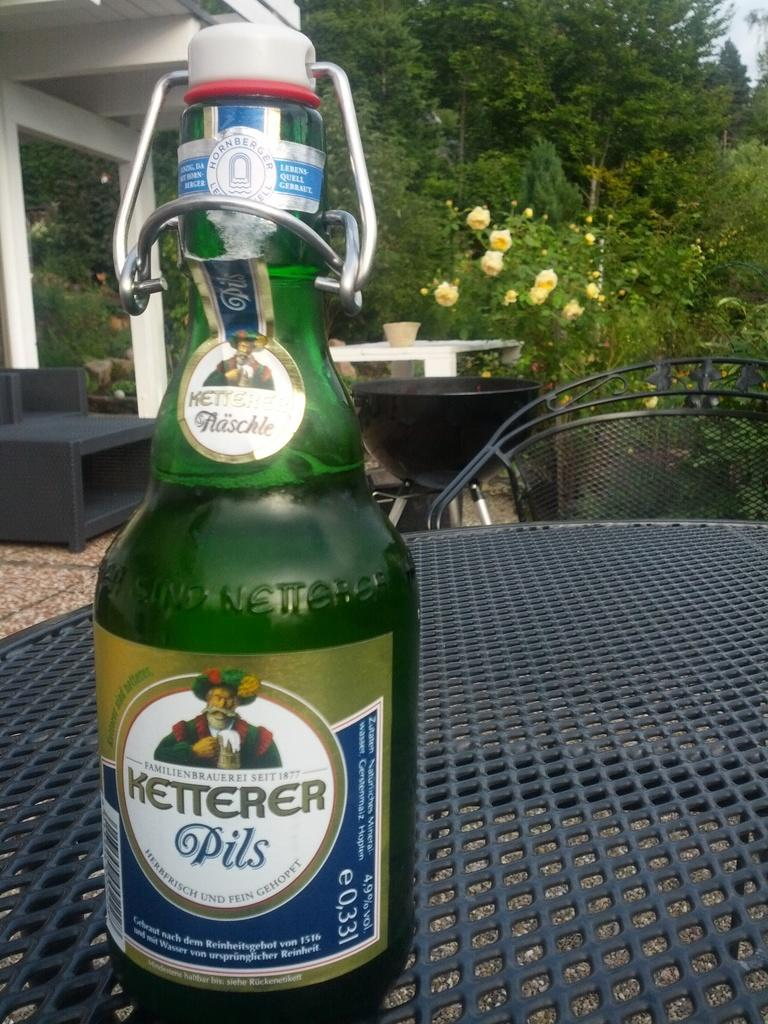<image>
Describe the image concisely. a green bottle of Ketterer Pils on a mesh outdoor table 